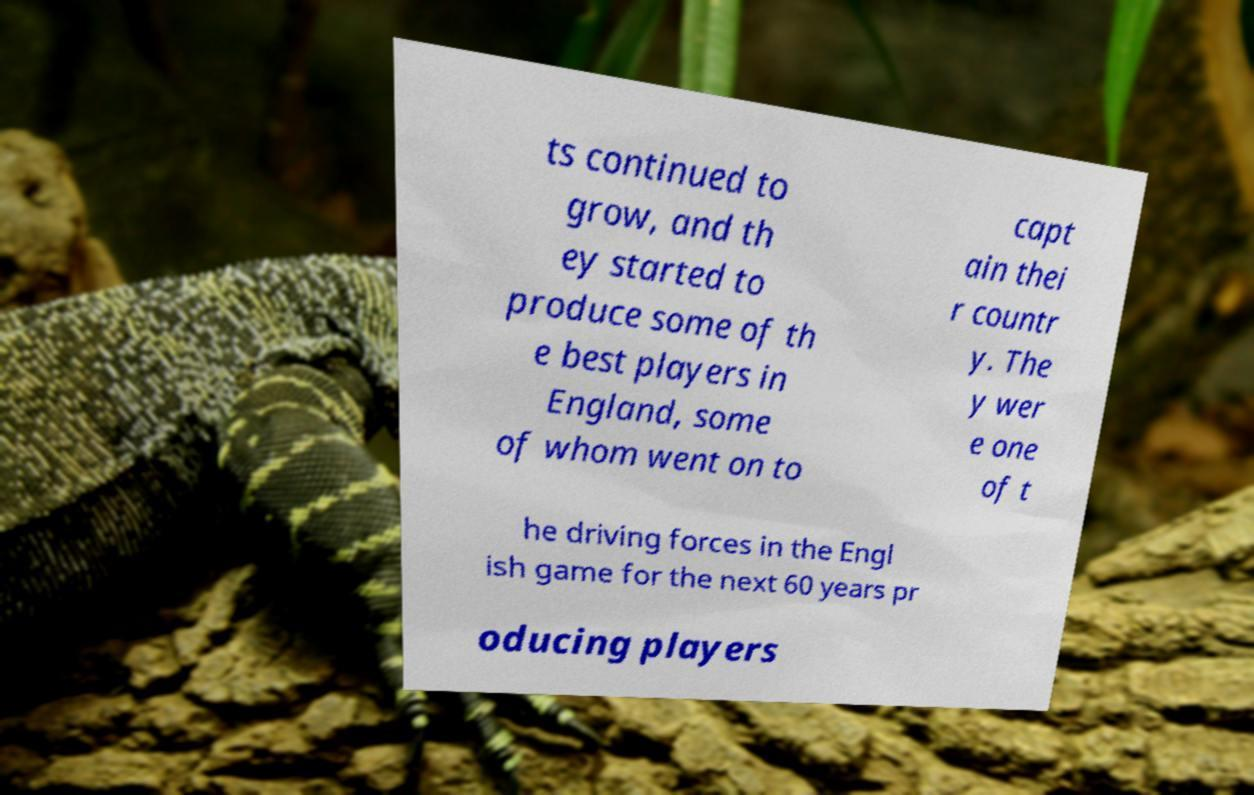Can you accurately transcribe the text from the provided image for me? ts continued to grow, and th ey started to produce some of th e best players in England, some of whom went on to capt ain thei r countr y. The y wer e one of t he driving forces in the Engl ish game for the next 60 years pr oducing players 